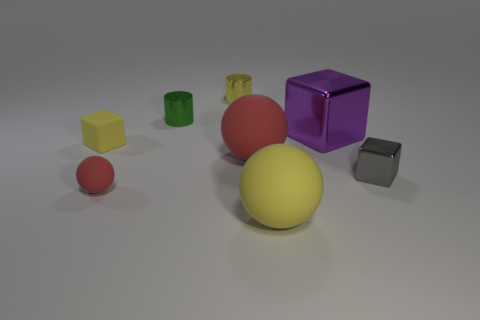The tiny metallic cube is what color?
Give a very brief answer. Gray. Is the size of the yellow rubber object to the left of the tiny green shiny cylinder the same as the red sphere that is on the left side of the yellow metal thing?
Keep it short and to the point. Yes. How big is the object that is both behind the tiny yellow rubber cube and right of the yellow cylinder?
Keep it short and to the point. Large. There is a tiny object that is the same shape as the large yellow object; what color is it?
Provide a short and direct response. Red. Is the number of blocks left of the gray metallic cube greater than the number of big yellow matte balls that are behind the yellow metallic thing?
Your answer should be very brief. Yes. What number of other things are there of the same shape as the yellow shiny object?
Make the answer very short. 1. There is a big object on the left side of the big yellow matte object; are there any small gray blocks in front of it?
Keep it short and to the point. Yes. How many large blocks are there?
Your answer should be very brief. 1. There is a tiny sphere; is its color the same as the cylinder behind the green metallic thing?
Keep it short and to the point. No. Is the number of large cubes greater than the number of large brown cubes?
Your answer should be very brief. Yes. 